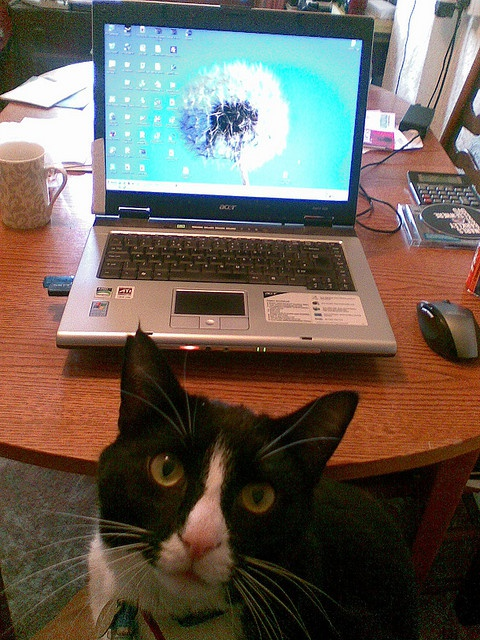Describe the objects in this image and their specific colors. I can see laptop in olive, lightblue, white, black, and cyan tones, dining table in olive, brown, black, and maroon tones, cat in olive, black, maroon, and gray tones, cup in olive, brown, and tan tones, and mouse in olive, black, gray, and maroon tones in this image. 